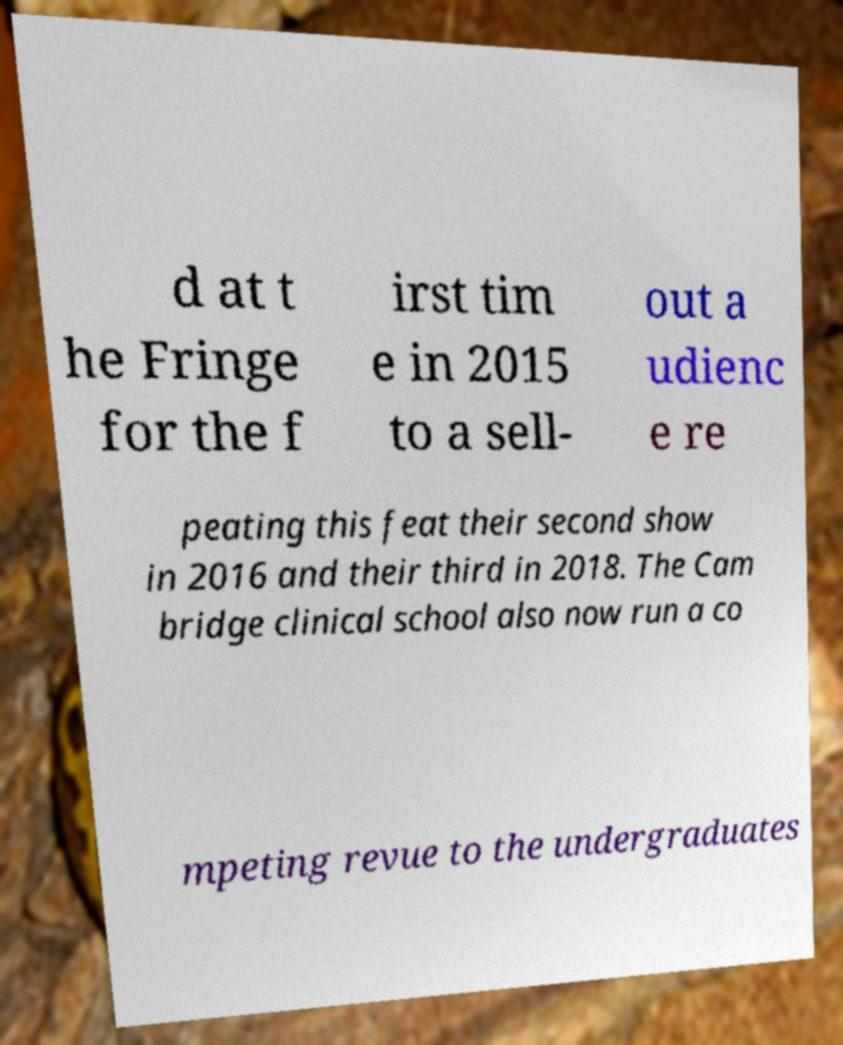I need the written content from this picture converted into text. Can you do that? d at t he Fringe for the f irst tim e in 2015 to a sell- out a udienc e re peating this feat their second show in 2016 and their third in 2018. The Cam bridge clinical school also now run a co mpeting revue to the undergraduates 